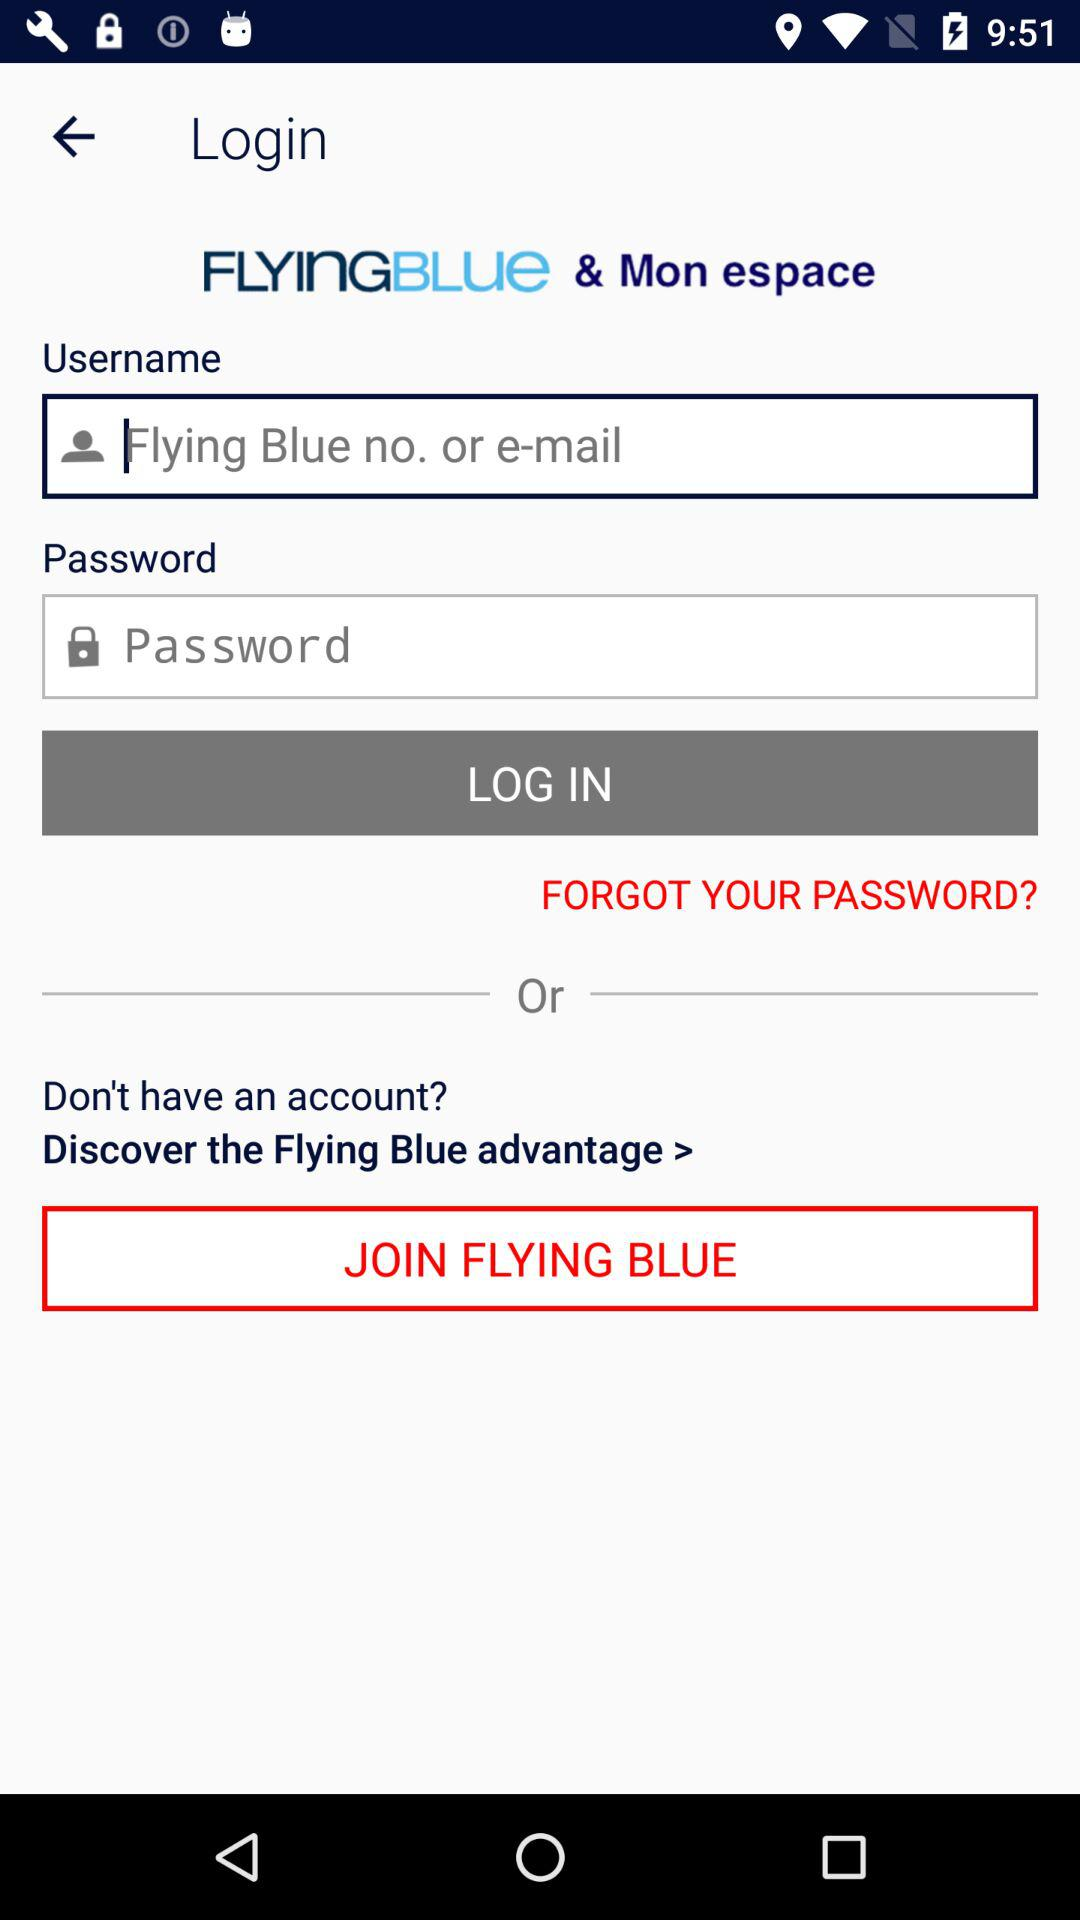What is the app name? The apps' names are "FLYINGBLUE" and "Mon espace". 